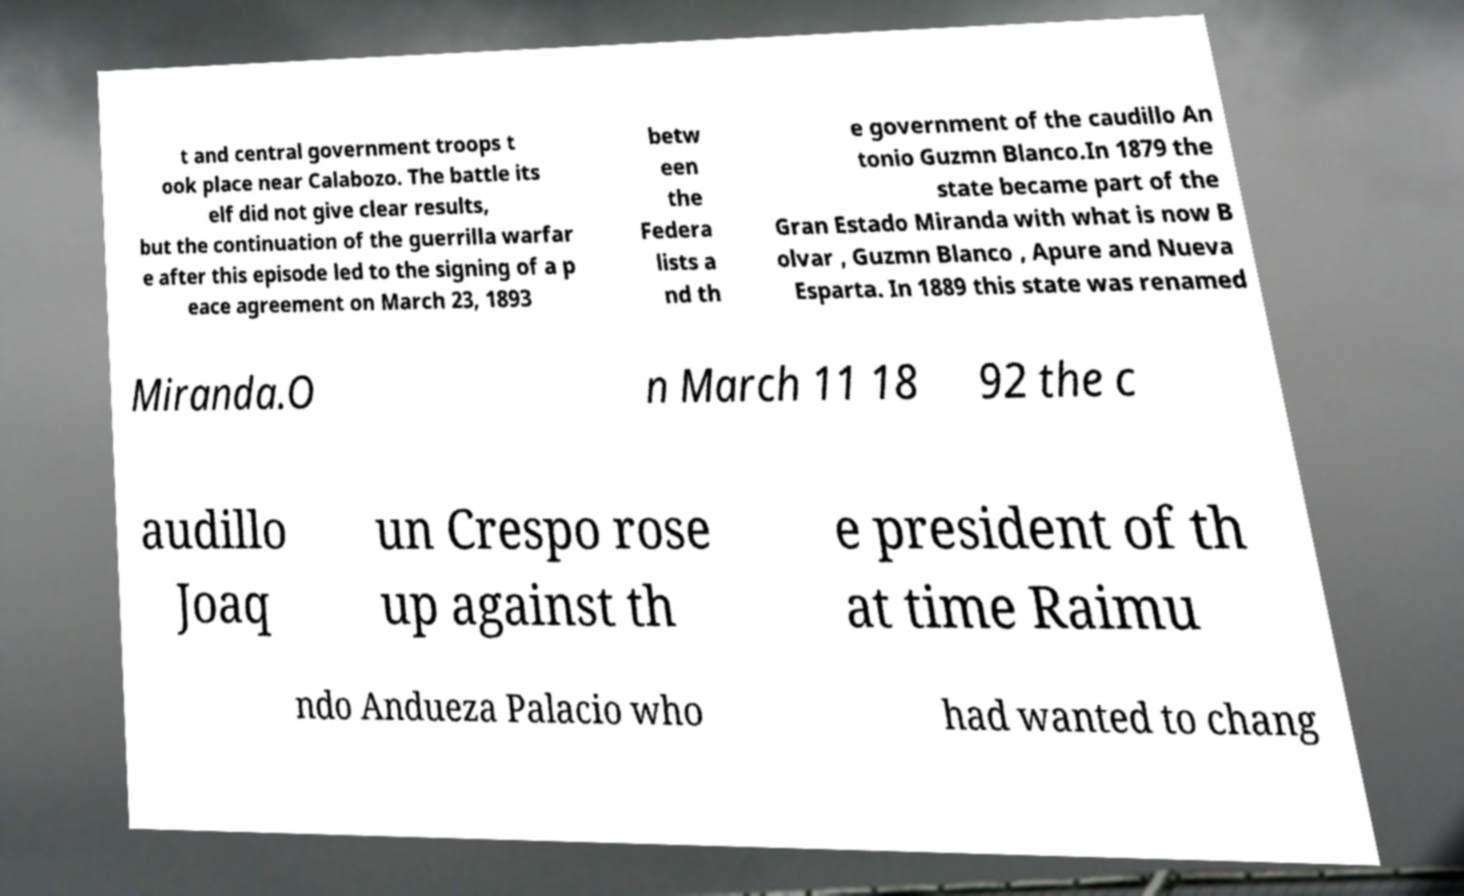Could you extract and type out the text from this image? t and central government troops t ook place near Calabozo. The battle its elf did not give clear results, but the continuation of the guerrilla warfar e after this episode led to the signing of a p eace agreement on March 23, 1893 betw een the Federa lists a nd th e government of the caudillo An tonio Guzmn Blanco.In 1879 the state became part of the Gran Estado Miranda with what is now B olvar , Guzmn Blanco , Apure and Nueva Esparta. In 1889 this state was renamed Miranda.O n March 11 18 92 the c audillo Joaq un Crespo rose up against th e president of th at time Raimu ndo Andueza Palacio who had wanted to chang 